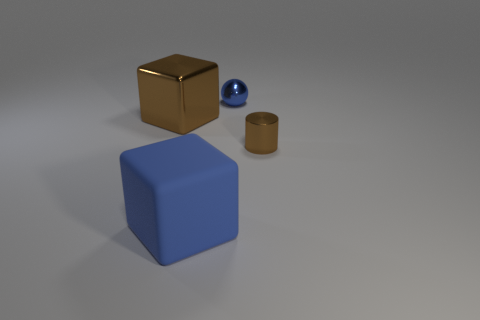What could be the context or purpose of this arrangement? The objects are arranged in a simple, clear manner which may suggest an educational purpose, such as demonstrating shapes and colors or could be part of a visual composition exploring minimalist design. 